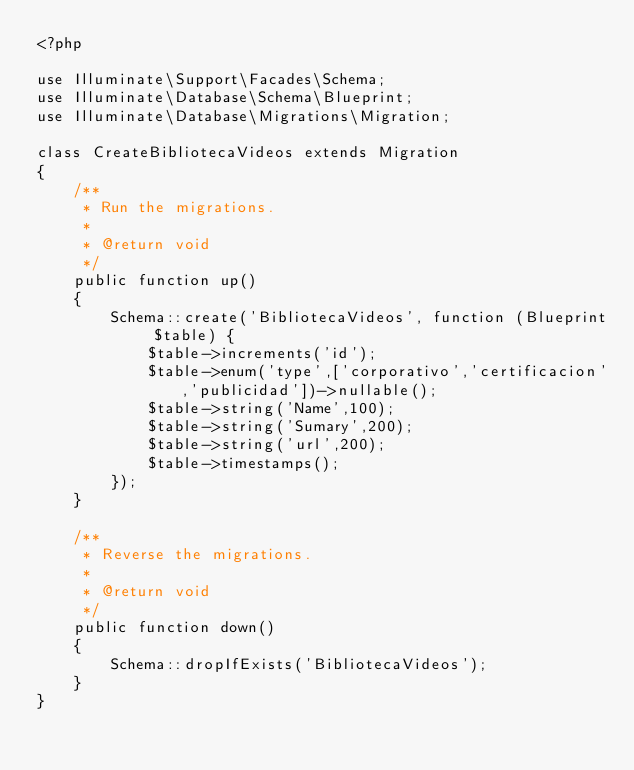Convert code to text. <code><loc_0><loc_0><loc_500><loc_500><_PHP_><?php

use Illuminate\Support\Facades\Schema;
use Illuminate\Database\Schema\Blueprint;
use Illuminate\Database\Migrations\Migration;

class CreateBibliotecaVideos extends Migration
{
    /**
     * Run the migrations.
     *
     * @return void
     */
    public function up()
    {
        Schema::create('BibliotecaVideos', function (Blueprint $table) {
            $table->increments('id');
            $table->enum('type',['corporativo','certificacion','publicidad'])->nullable();
            $table->string('Name',100);
            $table->string('Sumary',200);
            $table->string('url',200);
            $table->timestamps();
        });
    }

    /**
     * Reverse the migrations.
     *
     * @return void
     */
    public function down()
    {
        Schema::dropIfExists('BibliotecaVideos');
    }
}
</code> 